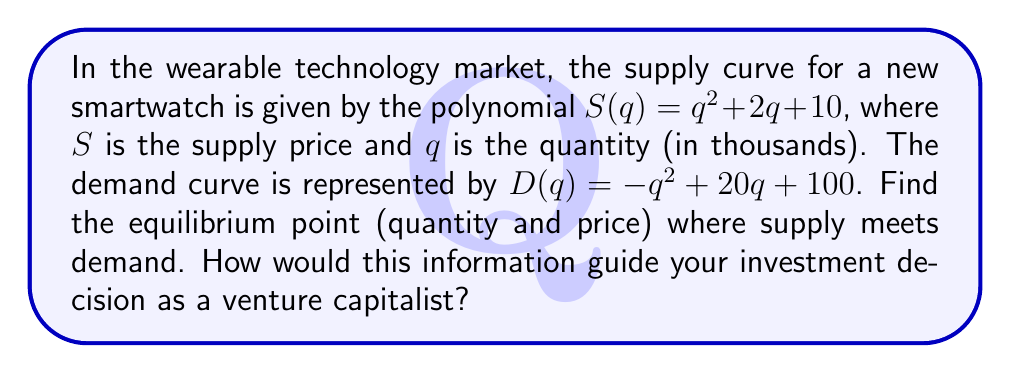Can you answer this question? To find the equilibrium point, we need to solve the system of equations where supply equals demand:

1) Set up the equation:
   $S(q) = D(q)$
   $q^2 + 2q + 10 = -q^2 + 20q + 100$

2) Rearrange the equation:
   $2q^2 - 18q - 90 = 0$

3) Simplify by dividing all terms by 2:
   $q^2 - 9q - 45 = 0$

4) Solve the quadratic equation using the quadratic formula:
   $q = \frac{-b \pm \sqrt{b^2 - 4ac}}{2a}$

   Where $a=1$, $b=-9$, and $c=-45$

   $q = \frac{9 \pm \sqrt{81 + 180}}{2} = \frac{9 \pm \sqrt{261}}{2}$

5) Simplify:
   $q = \frac{9 + \sqrt{261}}{2}$ (we discard the negative solution as quantity cannot be negative)

6) Calculate the approximate value:
   $q \approx 10.57$ thousand units

7) To find the equilibrium price, substitute this quantity into either the supply or demand equation:
   $S(10.57) = (10.57)^2 + 2(10.57) + 10 \approx 143.73$

Therefore, the equilibrium point is approximately (10.57, 143.73), representing 10,570 units at a price of $143.73.

As a venture capitalist, this information suggests a significant market demand for the smartwatch at a relatively high price point, indicating potential for profitability and scalability in the wearable technology sector.
Answer: Equilibrium: 10,570 units at $143.73 